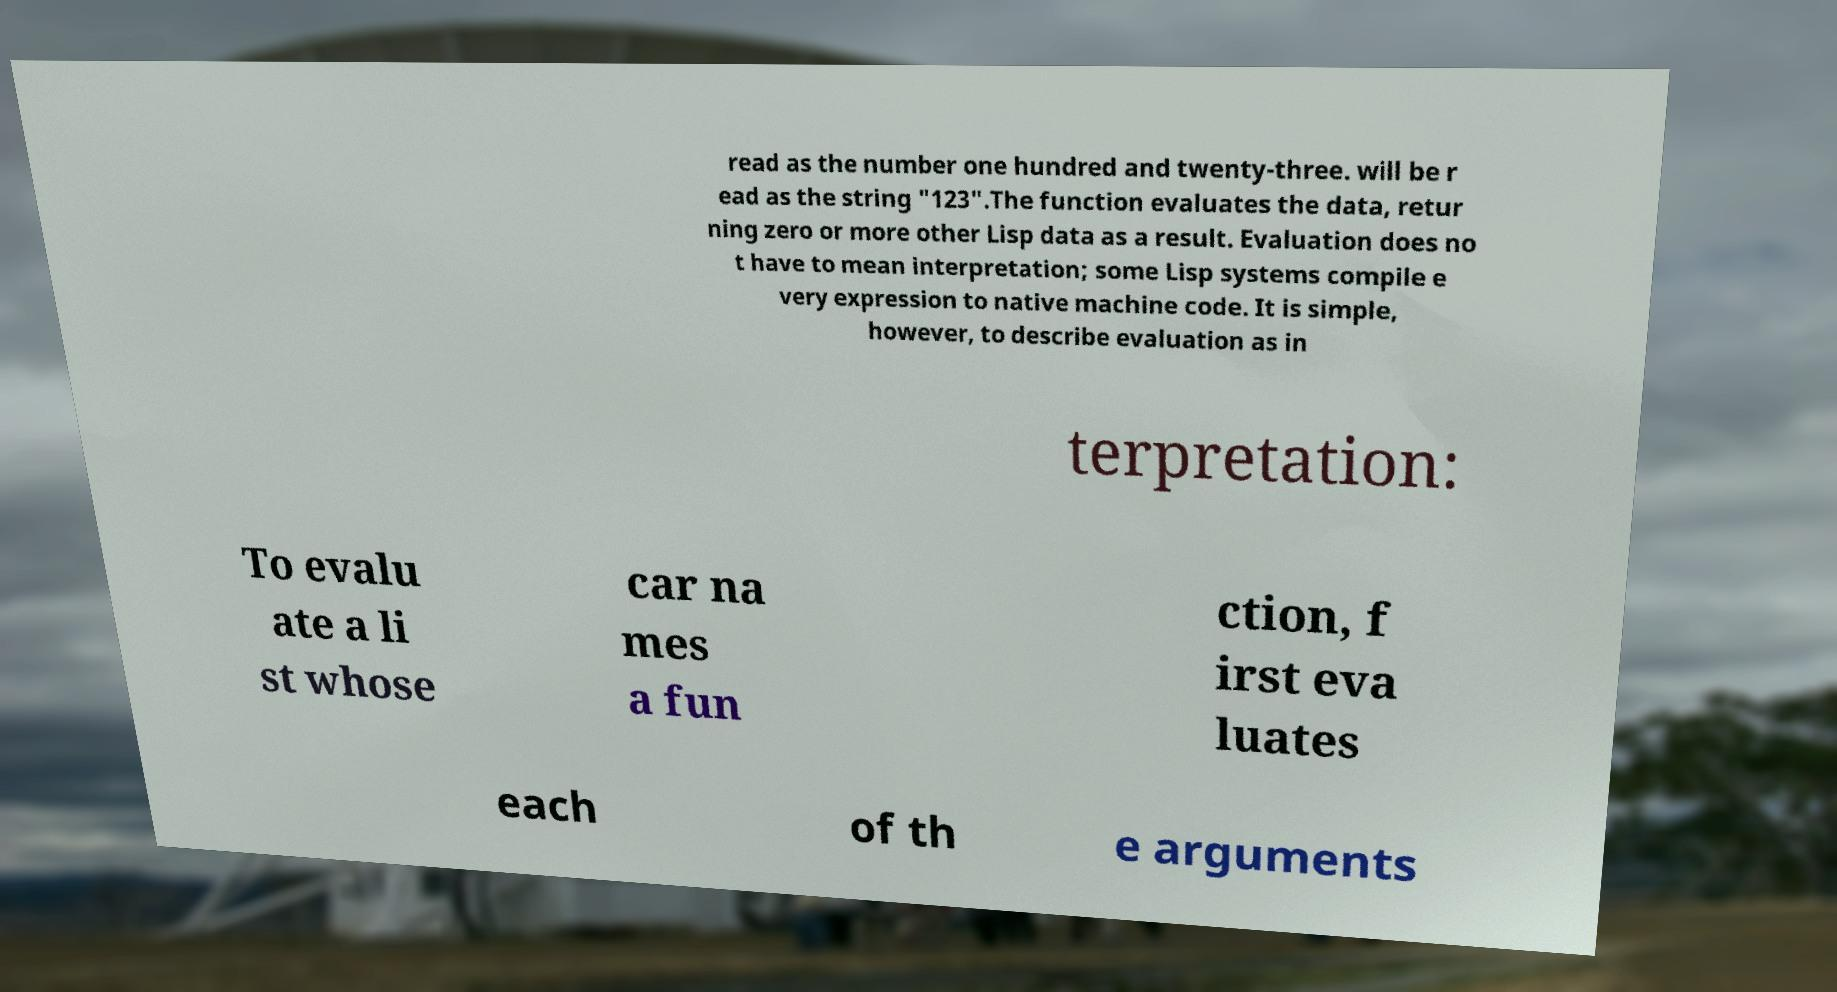Could you assist in decoding the text presented in this image and type it out clearly? read as the number one hundred and twenty-three. will be r ead as the string "123".The function evaluates the data, retur ning zero or more other Lisp data as a result. Evaluation does no t have to mean interpretation; some Lisp systems compile e very expression to native machine code. It is simple, however, to describe evaluation as in terpretation: To evalu ate a li st whose car na mes a fun ction, f irst eva luates each of th e arguments 